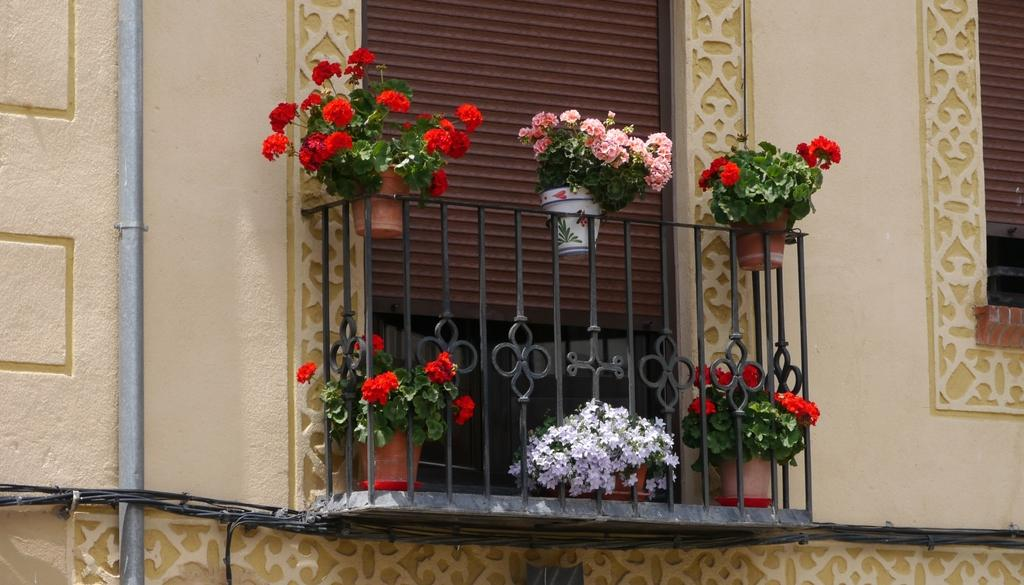What type of structure is visible in the image? There is a building in the image. What feature can be seen on the building? There is a balcony on the building. What is present on the balcony? The balcony has a railing and flower pots. What else can be seen on the left side of the image? There is a pipe on the left side of the image. What type of beef is being cooked on the balcony in the image? There is no beef or any cooking activity visible in the image. 